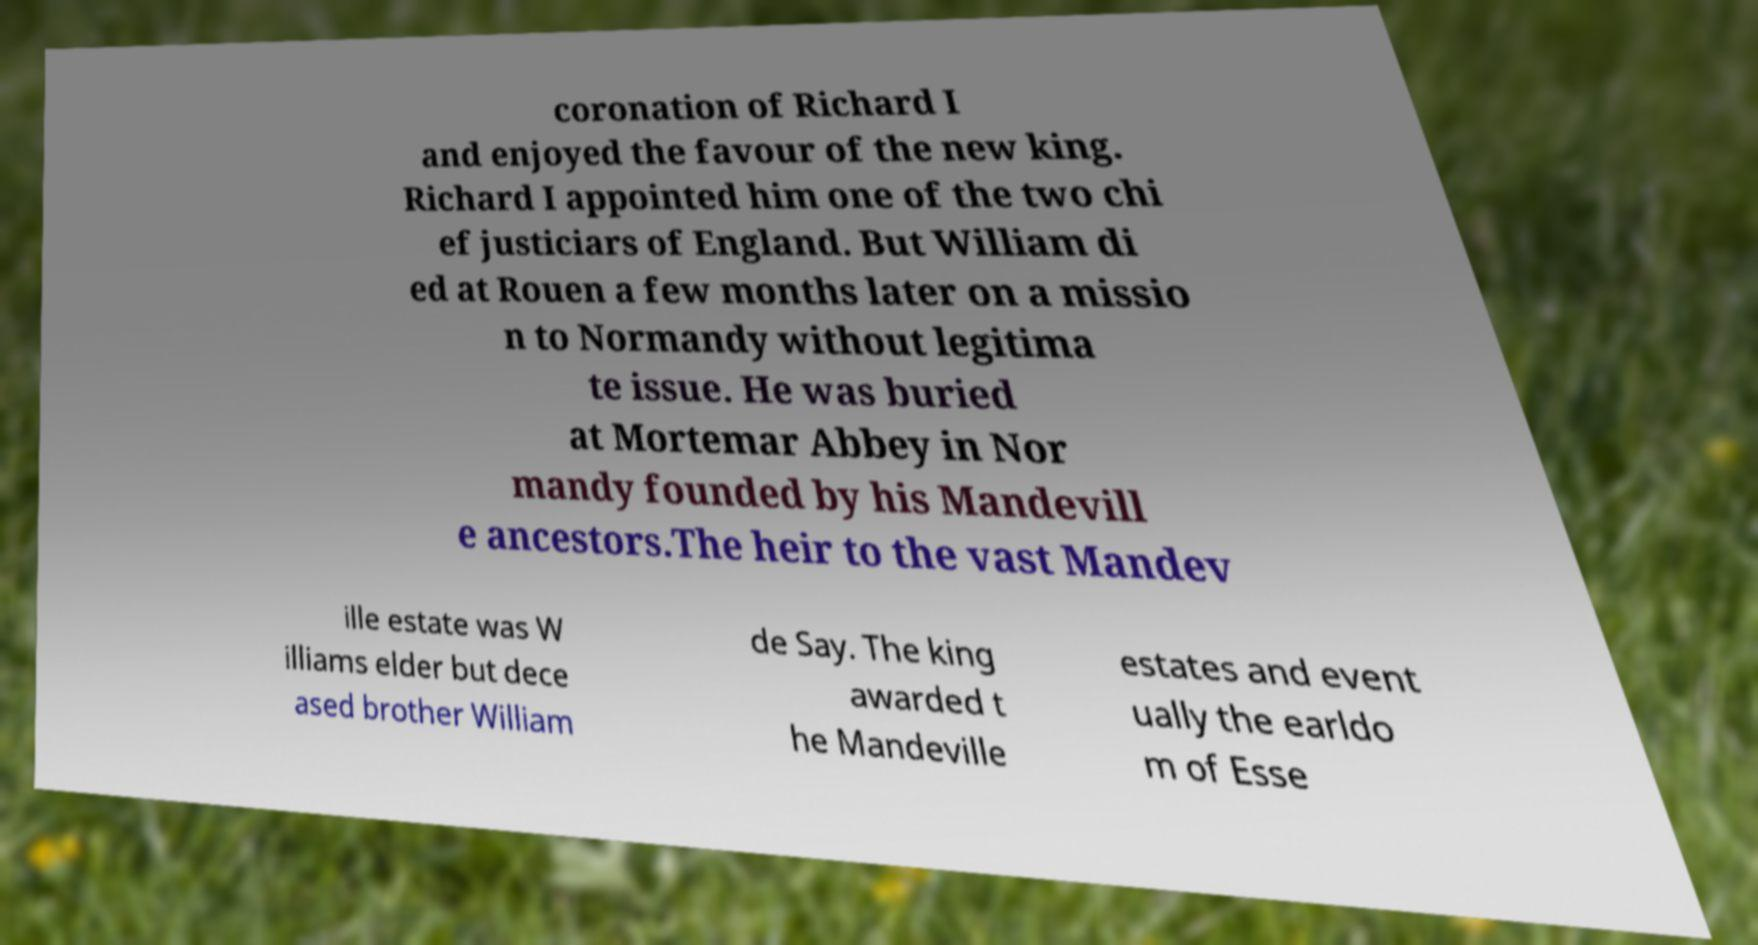For documentation purposes, I need the text within this image transcribed. Could you provide that? coronation of Richard I and enjoyed the favour of the new king. Richard I appointed him one of the two chi ef justiciars of England. But William di ed at Rouen a few months later on a missio n to Normandy without legitima te issue. He was buried at Mortemar Abbey in Nor mandy founded by his Mandevill e ancestors.The heir to the vast Mandev ille estate was W illiams elder but dece ased brother William de Say. The king awarded t he Mandeville estates and event ually the earldo m of Esse 